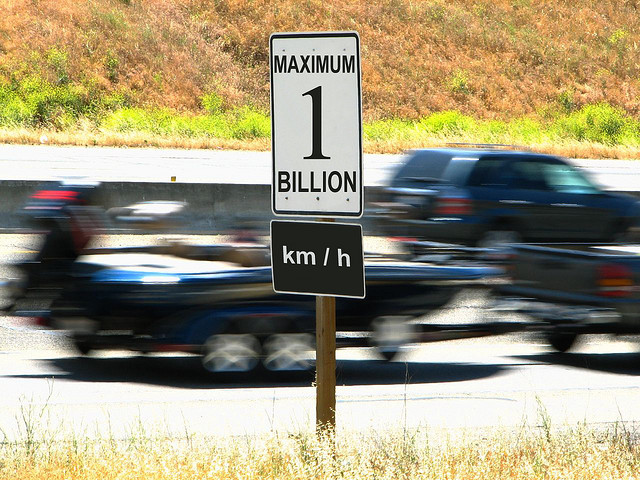Is the texture on the road sign retained?
A. Blurry
B. Lost
C. Yes
D. Smudged The texture on the road sign is well-preserved and the details are clear and legible, supporting the 'C. Yes' answer. The sign shows 'MAXIMUM 1 BILLION km/h', and despite the motion blur of the passing cars in the background, the text on the sign remains crisp and is not obscured. 